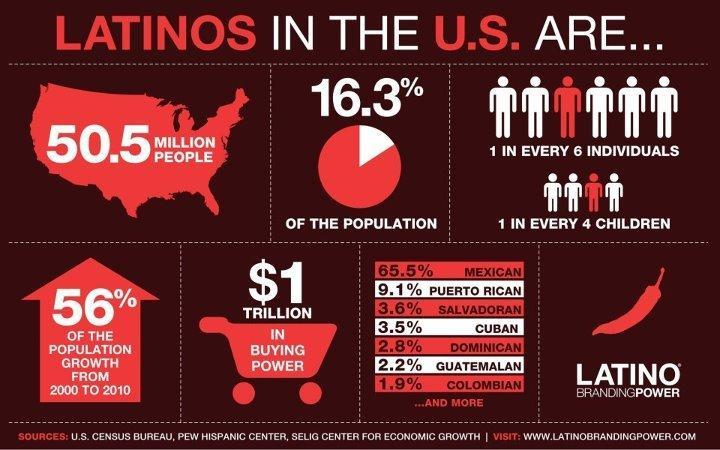Who constitutes majority of Latinos in the US?
Answer the question with a short phrase. Mexican 